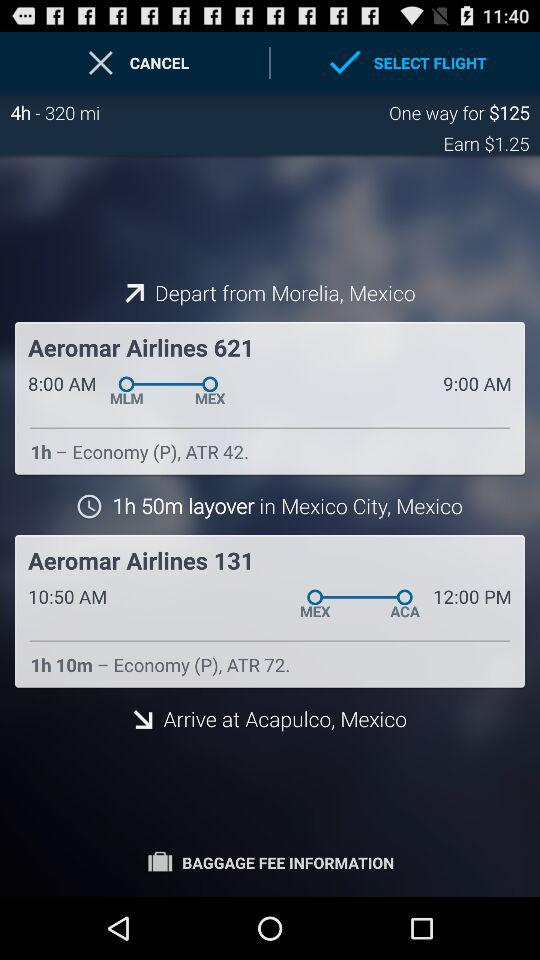What is the total journey time from Mexico City to Acapulco?
Answer the question using a single word or phrase. It is 1h 10m 